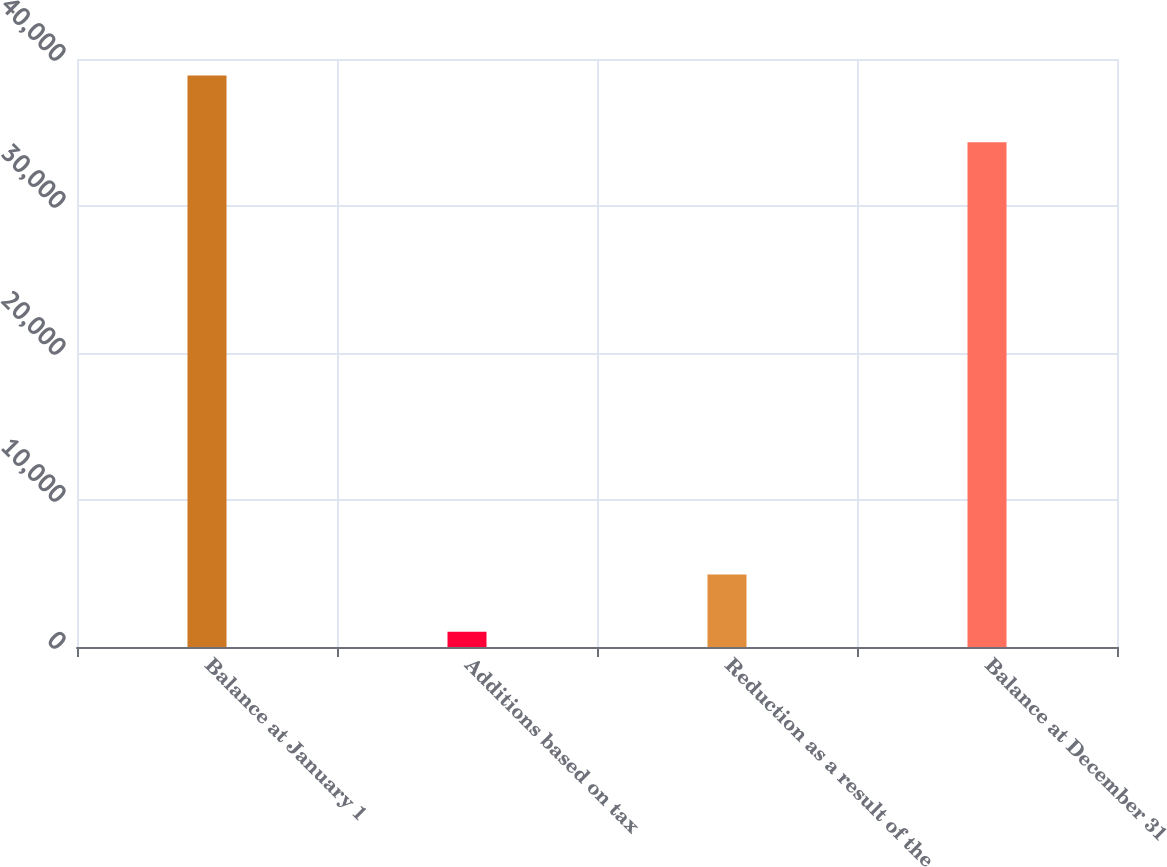<chart> <loc_0><loc_0><loc_500><loc_500><bar_chart><fcel>Balance at January 1<fcel>Additions based on tax<fcel>Reduction as a result of the<fcel>Balance at December 31<nl><fcel>38886<fcel>1037<fcel>4926<fcel>34337<nl></chart> 